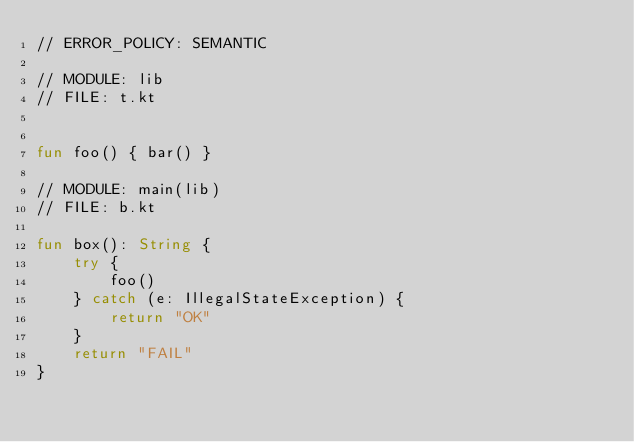<code> <loc_0><loc_0><loc_500><loc_500><_Kotlin_>// ERROR_POLICY: SEMANTIC

// MODULE: lib
// FILE: t.kt


fun foo() { bar() }

// MODULE: main(lib)
// FILE: b.kt

fun box(): String {
    try {
        foo()
    } catch (e: IllegalStateException) {
        return "OK"
    }
    return "FAIL"
}</code> 